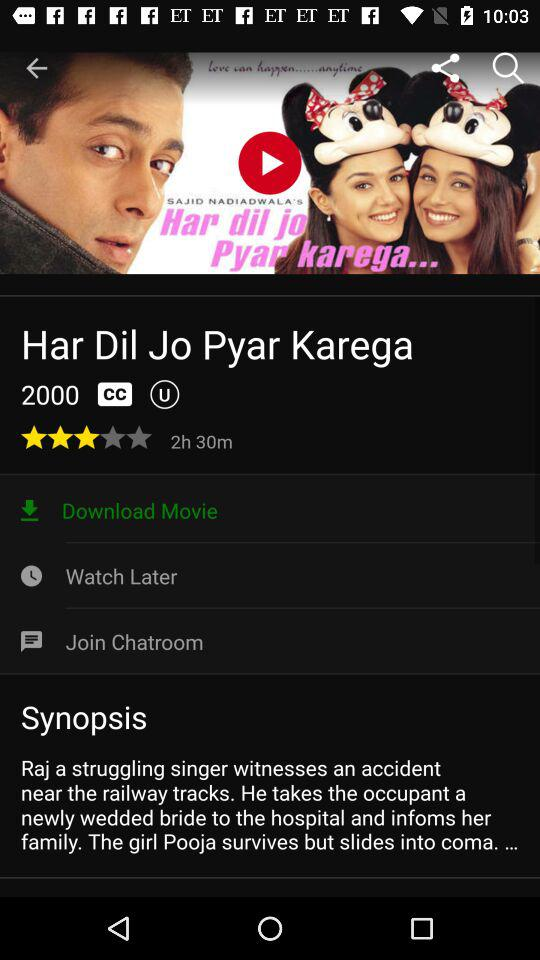What is the rating of the movie? The rating is 3 stars. 